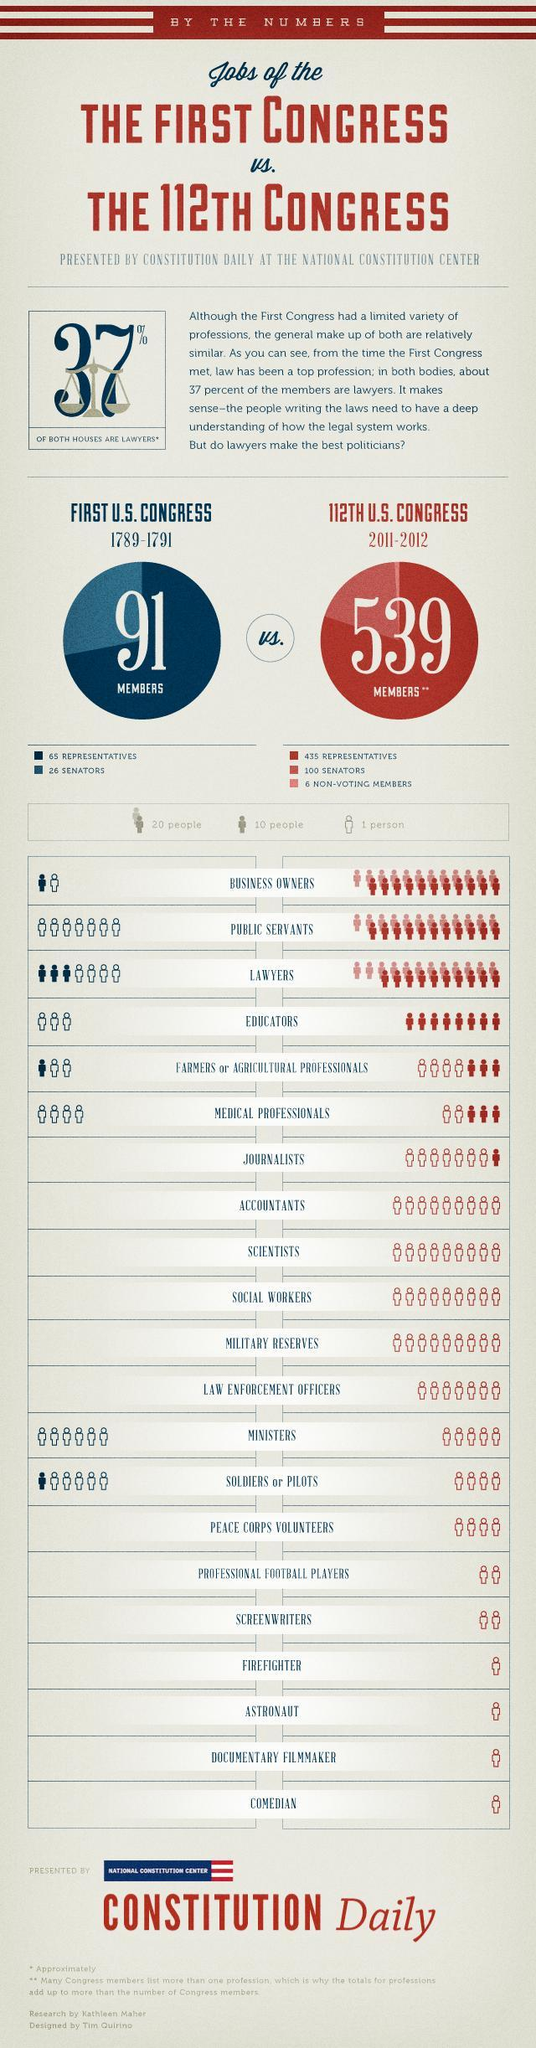what was the number of pilots or soldiers in first US congress?
Answer the question with a short phrase. 15 what was the number of ministers in first US congress? 6 what was the number of journalists in 112th US congress? 17 what was the number of comedians in first US congress? 0 what was the number of medical professionals in first US congress? 4 what was the total number of social workers and journalists in 112th US congress? 26 what was the number of lawyers in first US congress? 34 what was the number of public servants in first US congress? 7 what was the number of educators in 112th US congress? 80 what was the number of business owners in first US congress? 11 what was the number of medical professionals in 112th US congress? 32 what was the number of educators in first US congress? 3 what was the total number of documentary film makers and screen writers in 112th US congress? 3 